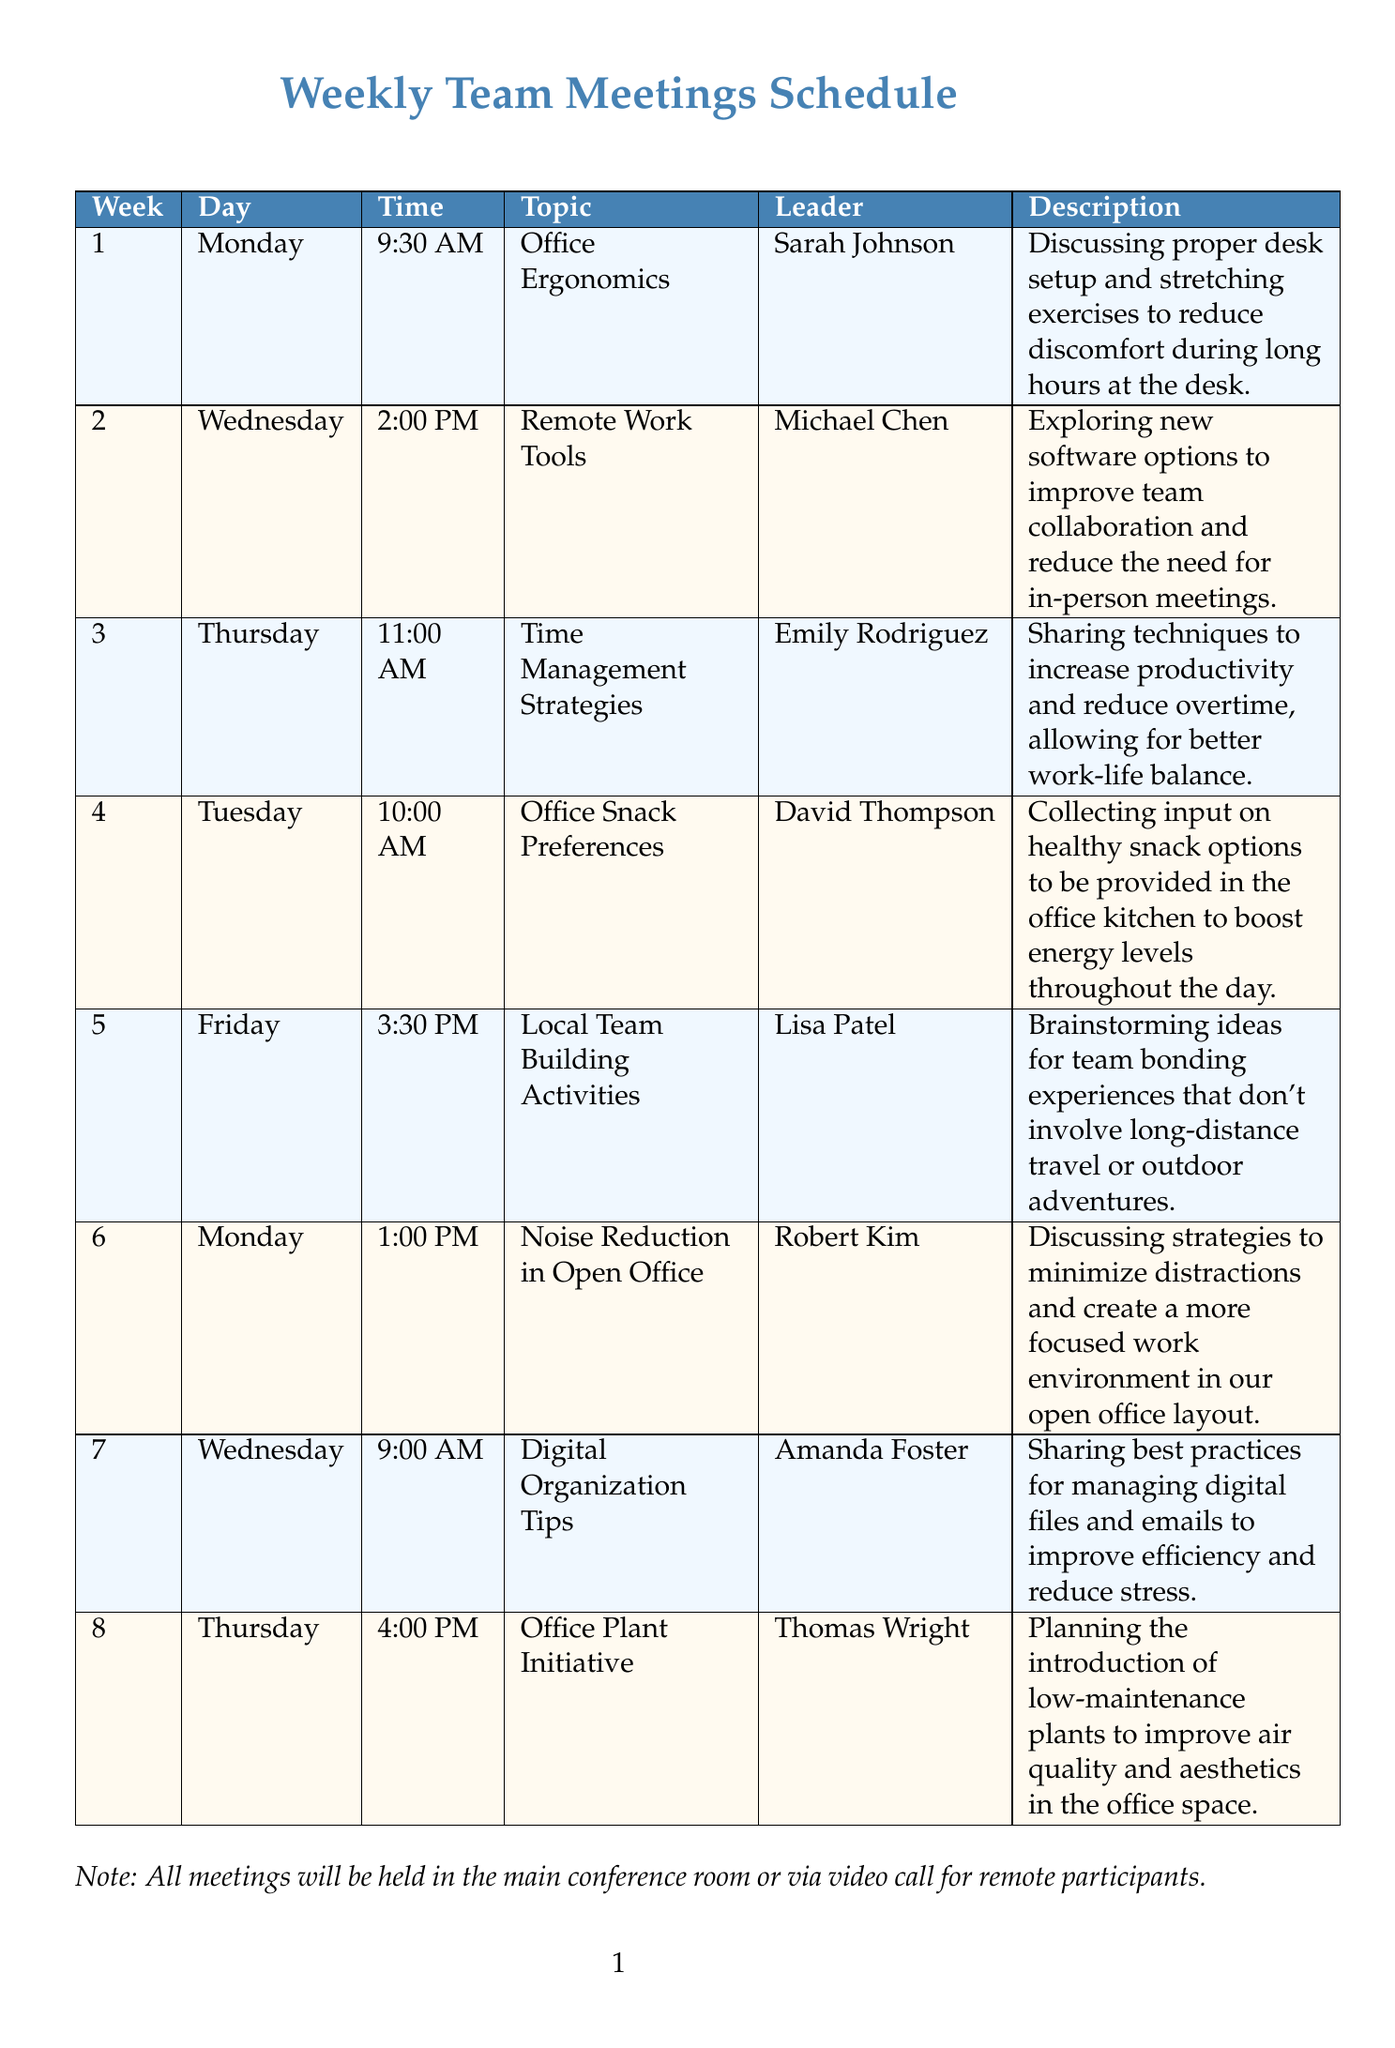what is the topic of week 5? The topic for week 5 as stated in the document is "Local Team Building Activities."
Answer: Local Team Building Activities who is leading the discussion on Remote Work Tools? The leader for the Remote Work Tools meeting is Michael Chen.
Answer: Michael Chen when is the meeting about Office Snack Preferences scheduled? The Office Snack Preferences meeting is scheduled for Tuesday at 10:00 AM.
Answer: Tuesday at 10:00 AM what is the time of the meeting in week 3? The meeting in week 3 is scheduled for 11:00 AM on Thursday.
Answer: 11:00 AM which week features a discussion on Digital Organization Tips? The Digital Organization Tips meeting is featured in week 7.
Answer: week 7 what is a key focus of the meeting on Noise Reduction in Open Office? The key focus is to minimize distractions in the open office layout.
Answer: minimize distractions which meeting occurs on a Friday and what is its topic? The meeting that occurs on a Friday is about "Local Team Building Activities."
Answer: Local Team Building Activities how many total meetings are scheduled in the document? There are a total of eight meetings detailed in the schedule.
Answer: eight what is the leader's name for the Office Plant Initiative meeting? The leader for the Office Plant Initiative meeting is Thomas Wright.
Answer: Thomas Wright 